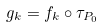<formula> <loc_0><loc_0><loc_500><loc_500>g _ { k } = f _ { k } \circ \tau _ { P _ { 0 } }</formula> 